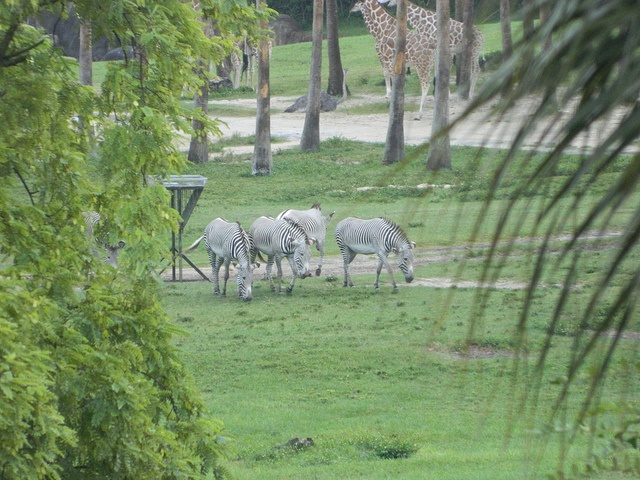Describe the objects in this image and their specific colors. I can see zebra in darkgreen, darkgray, gray, and lightgray tones, giraffe in darkgreen, darkgray, and gray tones, zebra in darkgreen, darkgray, gray, and lightgray tones, zebra in darkgreen, darkgray, gray, and lightgray tones, and giraffe in darkgreen, darkgray, gray, and lightgray tones in this image. 